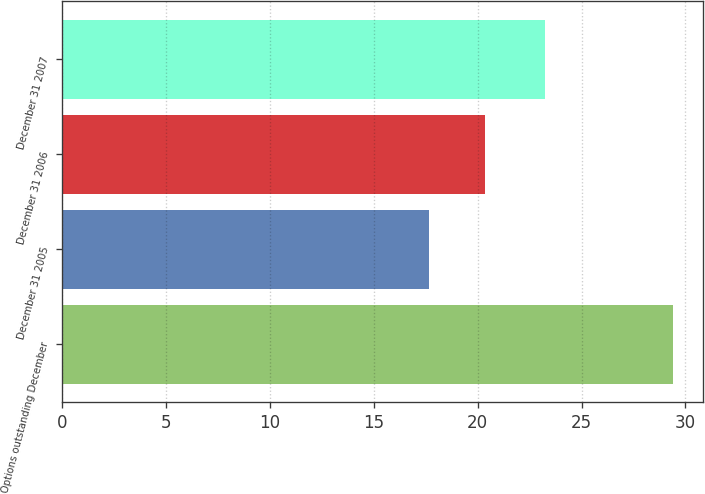<chart> <loc_0><loc_0><loc_500><loc_500><bar_chart><fcel>Options outstanding December<fcel>December 31 2005<fcel>December 31 2006<fcel>December 31 2007<nl><fcel>29.39<fcel>17.63<fcel>20.37<fcel>23.24<nl></chart> 